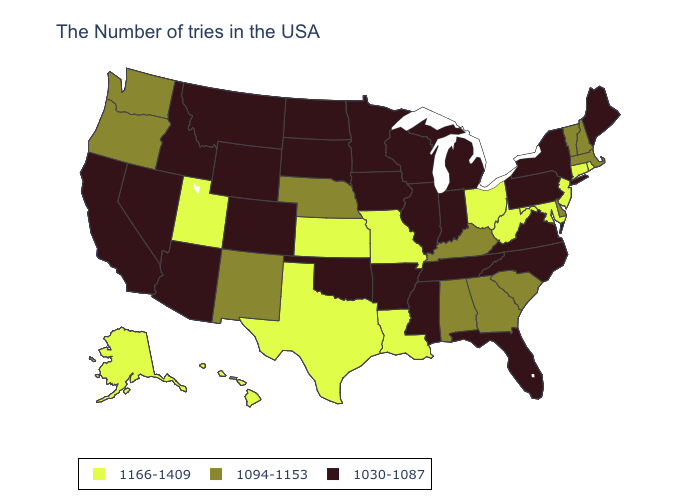Among the states that border Kansas , which have the highest value?
Concise answer only. Missouri. Which states have the highest value in the USA?
Answer briefly. Rhode Island, Connecticut, New Jersey, Maryland, West Virginia, Ohio, Louisiana, Missouri, Kansas, Texas, Utah, Alaska, Hawaii. Does the first symbol in the legend represent the smallest category?
Short answer required. No. What is the value of Missouri?
Write a very short answer. 1166-1409. What is the lowest value in states that border Tennessee?
Answer briefly. 1030-1087. Among the states that border South Carolina , which have the lowest value?
Keep it brief. North Carolina. Does Washington have the lowest value in the USA?
Write a very short answer. No. What is the highest value in states that border New Mexico?
Quick response, please. 1166-1409. Does Indiana have the highest value in the MidWest?
Answer briefly. No. What is the value of Washington?
Answer briefly. 1094-1153. Does Arkansas have the lowest value in the USA?
Answer briefly. Yes. Name the states that have a value in the range 1030-1087?
Give a very brief answer. Maine, New York, Pennsylvania, Virginia, North Carolina, Florida, Michigan, Indiana, Tennessee, Wisconsin, Illinois, Mississippi, Arkansas, Minnesota, Iowa, Oklahoma, South Dakota, North Dakota, Wyoming, Colorado, Montana, Arizona, Idaho, Nevada, California. Does Washington have a higher value than Wyoming?
Give a very brief answer. Yes. Does Alaska have the same value as Iowa?
Quick response, please. No. Which states have the highest value in the USA?
Be succinct. Rhode Island, Connecticut, New Jersey, Maryland, West Virginia, Ohio, Louisiana, Missouri, Kansas, Texas, Utah, Alaska, Hawaii. 